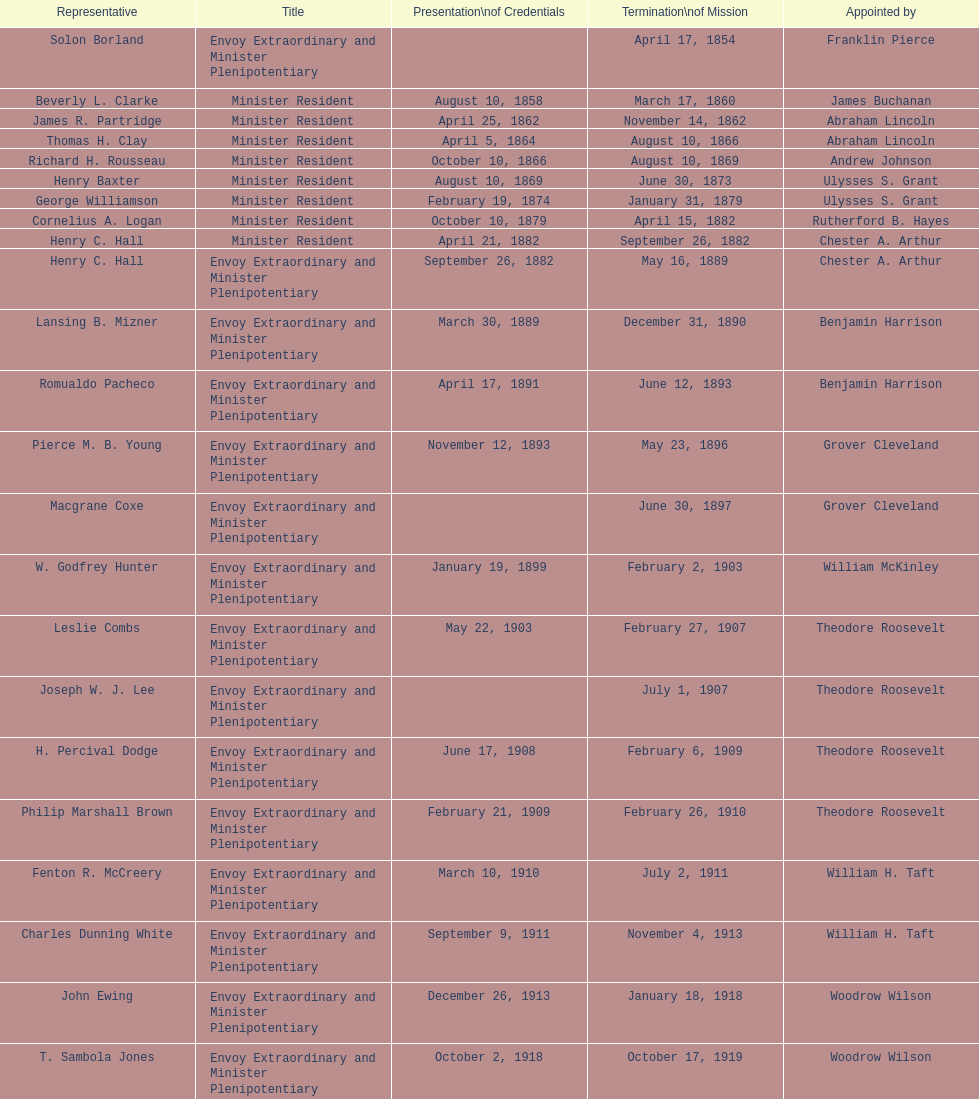Is solon borland a representative? Yes. Parse the full table. {'header': ['Representative', 'Title', 'Presentation\\nof Credentials', 'Termination\\nof Mission', 'Appointed by'], 'rows': [['Solon Borland', 'Envoy Extraordinary and Minister Plenipotentiary', '', 'April 17, 1854', 'Franklin Pierce'], ['Beverly L. Clarke', 'Minister Resident', 'August 10, 1858', 'March 17, 1860', 'James Buchanan'], ['James R. Partridge', 'Minister Resident', 'April 25, 1862', 'November 14, 1862', 'Abraham Lincoln'], ['Thomas H. Clay', 'Minister Resident', 'April 5, 1864', 'August 10, 1866', 'Abraham Lincoln'], ['Richard H. Rousseau', 'Minister Resident', 'October 10, 1866', 'August 10, 1869', 'Andrew Johnson'], ['Henry Baxter', 'Minister Resident', 'August 10, 1869', 'June 30, 1873', 'Ulysses S. Grant'], ['George Williamson', 'Minister Resident', 'February 19, 1874', 'January 31, 1879', 'Ulysses S. Grant'], ['Cornelius A. Logan', 'Minister Resident', 'October 10, 1879', 'April 15, 1882', 'Rutherford B. Hayes'], ['Henry C. Hall', 'Minister Resident', 'April 21, 1882', 'September 26, 1882', 'Chester A. Arthur'], ['Henry C. Hall', 'Envoy Extraordinary and Minister Plenipotentiary', 'September 26, 1882', 'May 16, 1889', 'Chester A. Arthur'], ['Lansing B. Mizner', 'Envoy Extraordinary and Minister Plenipotentiary', 'March 30, 1889', 'December 31, 1890', 'Benjamin Harrison'], ['Romualdo Pacheco', 'Envoy Extraordinary and Minister Plenipotentiary', 'April 17, 1891', 'June 12, 1893', 'Benjamin Harrison'], ['Pierce M. B. Young', 'Envoy Extraordinary and Minister Plenipotentiary', 'November 12, 1893', 'May 23, 1896', 'Grover Cleveland'], ['Macgrane Coxe', 'Envoy Extraordinary and Minister Plenipotentiary', '', 'June 30, 1897', 'Grover Cleveland'], ['W. Godfrey Hunter', 'Envoy Extraordinary and Minister Plenipotentiary', 'January 19, 1899', 'February 2, 1903', 'William McKinley'], ['Leslie Combs', 'Envoy Extraordinary and Minister Plenipotentiary', 'May 22, 1903', 'February 27, 1907', 'Theodore Roosevelt'], ['Joseph W. J. Lee', 'Envoy Extraordinary and Minister Plenipotentiary', '', 'July 1, 1907', 'Theodore Roosevelt'], ['H. Percival Dodge', 'Envoy Extraordinary and Minister Plenipotentiary', 'June 17, 1908', 'February 6, 1909', 'Theodore Roosevelt'], ['Philip Marshall Brown', 'Envoy Extraordinary and Minister Plenipotentiary', 'February 21, 1909', 'February 26, 1910', 'Theodore Roosevelt'], ['Fenton R. McCreery', 'Envoy Extraordinary and Minister Plenipotentiary', 'March 10, 1910', 'July 2, 1911', 'William H. Taft'], ['Charles Dunning White', 'Envoy Extraordinary and Minister Plenipotentiary', 'September 9, 1911', 'November 4, 1913', 'William H. Taft'], ['John Ewing', 'Envoy Extraordinary and Minister Plenipotentiary', 'December 26, 1913', 'January 18, 1918', 'Woodrow Wilson'], ['T. Sambola Jones', 'Envoy Extraordinary and Minister Plenipotentiary', 'October 2, 1918', 'October 17, 1919', 'Woodrow Wilson'], ['Franklin E. Morales', 'Envoy Extraordinary and Minister Plenipotentiary', 'January 18, 1922', 'March 2, 1925', 'Warren G. Harding'], ['George T. Summerlin', 'Envoy Extraordinary and Minister Plenipotentiary', 'November 21, 1925', 'December 17, 1929', 'Calvin Coolidge'], ['Julius G. Lay', 'Envoy Extraordinary and Minister Plenipotentiary', 'May 31, 1930', 'March 17, 1935', 'Herbert Hoover'], ['Leo J. Keena', 'Envoy Extraordinary and Minister Plenipotentiary', 'July 19, 1935', 'May 1, 1937', 'Franklin D. Roosevelt'], ['John Draper Erwin', 'Envoy Extraordinary and Minister Plenipotentiary', 'September 8, 1937', 'April 27, 1943', 'Franklin D. Roosevelt'], ['John Draper Erwin', 'Ambassador Extraordinary and Plenipotentiary', 'April 27, 1943', 'April 16, 1947', 'Franklin D. Roosevelt'], ['Paul C. Daniels', 'Ambassador Extraordinary and Plenipotentiary', 'June 23, 1947', 'October 30, 1947', 'Harry S. Truman'], ['Herbert S. Bursley', 'Ambassador Extraordinary and Plenipotentiary', 'May 15, 1948', 'December 12, 1950', 'Harry S. Truman'], ['John Draper Erwin', 'Ambassador Extraordinary and Plenipotentiary', 'March 14, 1951', 'February 28, 1954', 'Harry S. Truman'], ['Whiting Willauer', 'Ambassador Extraordinary and Plenipotentiary', 'March 5, 1954', 'March 24, 1958', 'Dwight D. Eisenhower'], ['Robert Newbegin', 'Ambassador Extraordinary and Plenipotentiary', 'April 30, 1958', 'August 3, 1960', 'Dwight D. Eisenhower'], ['Charles R. Burrows', 'Ambassador Extraordinary and Plenipotentiary', 'November 3, 1960', 'June 28, 1965', 'Dwight D. Eisenhower'], ['Joseph J. Jova', 'Ambassador Extraordinary and Plenipotentiary', 'July 12, 1965', 'June 21, 1969', 'Lyndon B. Johnson'], ['Hewson A. Ryan', 'Ambassador Extraordinary and Plenipotentiary', 'November 5, 1969', 'May 30, 1973', 'Richard Nixon'], ['Phillip V. Sanchez', 'Ambassador Extraordinary and Plenipotentiary', 'June 15, 1973', 'July 17, 1976', 'Richard Nixon'], ['Ralph E. Becker', 'Ambassador Extraordinary and Plenipotentiary', 'October 27, 1976', 'August 1, 1977', 'Gerald Ford'], ['Mari-Luci Jaramillo', 'Ambassador Extraordinary and Plenipotentiary', 'October 27, 1977', 'September 19, 1980', 'Jimmy Carter'], ['Jack R. Binns', 'Ambassador Extraordinary and Plenipotentiary', 'October 10, 1980', 'October 31, 1981', 'Jimmy Carter'], ['John D. Negroponte', 'Ambassador Extraordinary and Plenipotentiary', 'November 11, 1981', 'May 30, 1985', 'Ronald Reagan'], ['John Arthur Ferch', 'Ambassador Extraordinary and Plenipotentiary', 'August 22, 1985', 'July 9, 1986', 'Ronald Reagan'], ['Everett Ellis Briggs', 'Ambassador Extraordinary and Plenipotentiary', 'November 4, 1986', 'June 15, 1989', 'Ronald Reagan'], ['Cresencio S. Arcos, Jr.', 'Ambassador Extraordinary and Plenipotentiary', 'January 29, 1990', 'July 1, 1993', 'George H. W. Bush'], ['William Thornton Pryce', 'Ambassador Extraordinary and Plenipotentiary', 'July 21, 1993', 'August 15, 1996', 'Bill Clinton'], ['James F. Creagan', 'Ambassador Extraordinary and Plenipotentiary', 'August 29, 1996', 'July 20, 1999', 'Bill Clinton'], ['Frank Almaguer', 'Ambassador Extraordinary and Plenipotentiary', 'August 25, 1999', 'September 5, 2002', 'Bill Clinton'], ['Larry Leon Palmer', 'Ambassador Extraordinary and Plenipotentiary', 'October 8, 2002', 'May 7, 2005', 'George W. Bush'], ['Charles A. Ford', 'Ambassador Extraordinary and Plenipotentiary', 'November 8, 2005', 'ca. April 2008', 'George W. Bush'], ['Hugo Llorens', 'Ambassador Extraordinary and Plenipotentiary', 'September 19, 2008', 'ca. July 2011', 'George W. Bush'], ['Lisa Kubiske', 'Ambassador Extraordinary and Plenipotentiary', 'July 26, 2011', 'Incumbent', 'Barack Obama']]} 